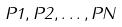Convert formula to latex. <formula><loc_0><loc_0><loc_500><loc_500>P 1 , P 2 , \dots , P N</formula> 